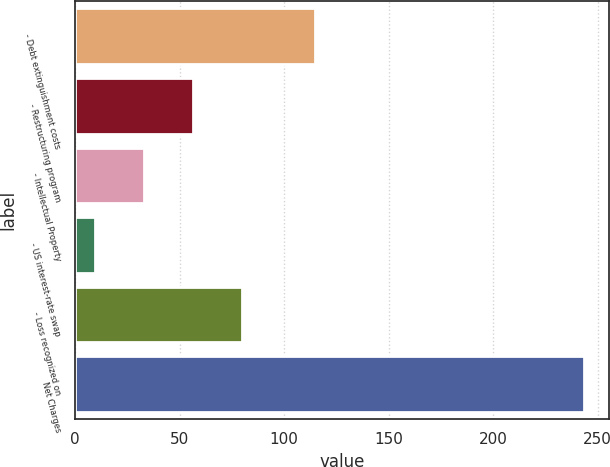Convert chart to OTSL. <chart><loc_0><loc_0><loc_500><loc_500><bar_chart><fcel>- Debt extinguishment costs<fcel>- Restructuring program<fcel>- Intellectual Property<fcel>- US interest-rate swap<fcel>- Loss recognized on<fcel>Net Charges<nl><fcel>114.9<fcel>56.38<fcel>32.99<fcel>9.6<fcel>79.77<fcel>243.5<nl></chart> 